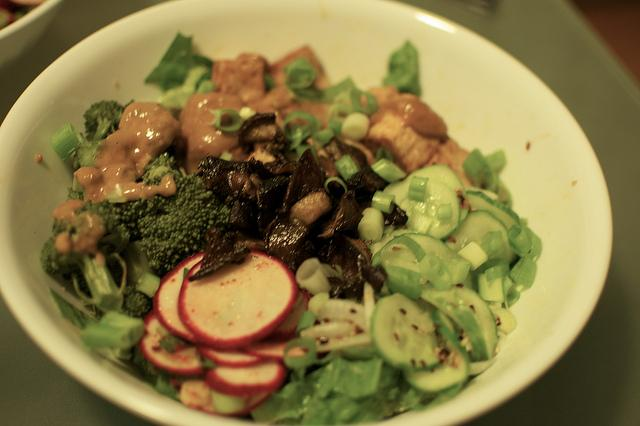What animal would most enjoy the food in the bowl? Please explain your reasoning. sheep. They are herbivores. herbivores eat plants. these are all plant based foods. 